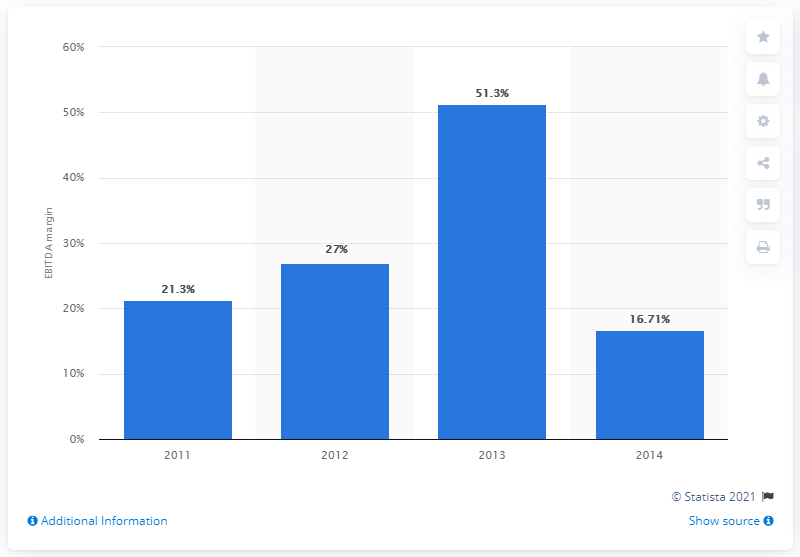Identify some key points in this picture. Burger King's earnings before interest, taxes, depreciation and amortization (EBITDA) increased by 51.3% between 2012 and 2013. 